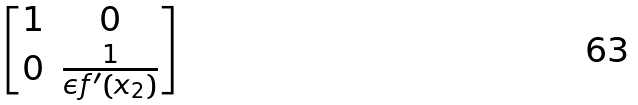Convert formula to latex. <formula><loc_0><loc_0><loc_500><loc_500>\begin{bmatrix} 1 & 0 \\ 0 & \frac { 1 } { \epsilon f ^ { \prime } ( x _ { 2 } ) } \end{bmatrix}</formula> 